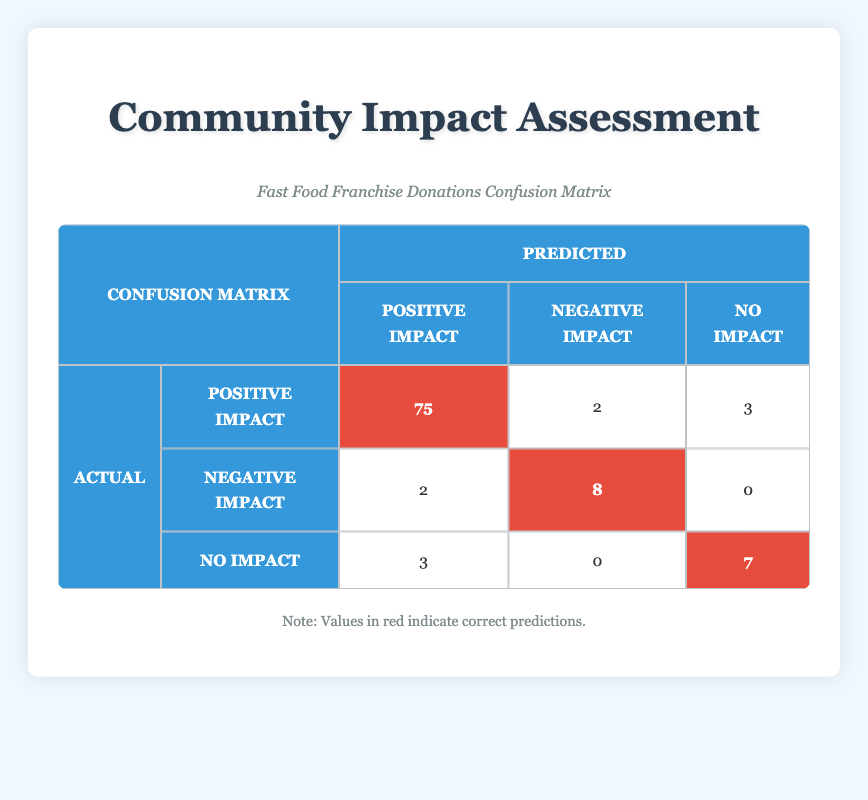What is the total number of positive impact predictions? The number of positive impact predictions can be found by adding the true positives and false positives for positive impact. That is 75 (true positive) + 2 (false positive) + 3 (false positive from no impact) = 80.
Answer: 80 How many actual negative impacts were correctly predicted? The actual negative impact row indicates 8 true negatives, which are the correct predictions for negative impact.
Answer: 8 What is the total number of cases predicted to have no impact? For no impact predictions, we look at the column under "Predicted". The values are 3 (false positive from positive impact) + 0 (true negative from negative impact) + 7 (true positives for no impact) = 10.
Answer: 10 Did the model make more incorrect predictions for positive impacts than for negative impacts? To determine this, we can compare the number of false positives and false negatives. For positive impact, there were 5 false negatives and 2 false positives for negative impact. Thus, 5 > 2, so the model did make more incorrect predictions for positive impacts.
Answer: Yes What percentage of actual positive impacts were correctly identified? The percentage is calculated by dividing the true positives by the total actual positives. Thus, (75 true positives / 80 total positives) * 100 = 93.75%.
Answer: 93.75% What is the overall accuracy of the predictions? Overall accuracy can be found by adding the true positives and true negatives and dividing that by the total cases. Thus, (75 + 8 + 7) / (80 + 10 + 10) = 90/100 = 90%.
Answer: 90% What is the difference between the number of true positives and true negatives? We can compute the difference by taking the number of true positives (75) and subtracting the number of true negatives (8), resulting in 75 - 8 = 67.
Answer: 67 How many total responses were categorized as having no impact? The total categorized as having no impact includes true positives (7), false negatives (0 for negative impact), and false positives (3 from positive impact) which sums up to 10.
Answer: 10 What proportion of the cases were predicted to have a negative impact? The total prediction for negative impact is the sum of true negatives (8) and false positives (2). So it's 10 out of 100 total cases, which gives a proportion of 10/100 = 0.1 or 10%.
Answer: 10% 